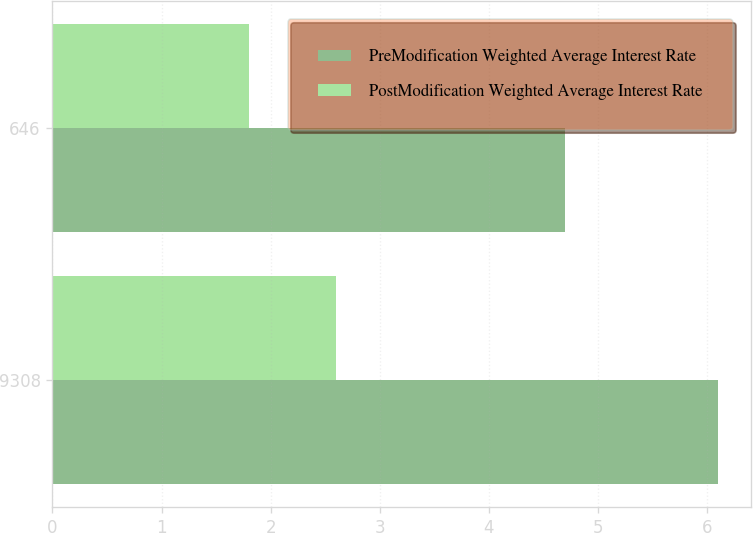<chart> <loc_0><loc_0><loc_500><loc_500><stacked_bar_chart><ecel><fcel>9308<fcel>646<nl><fcel>PreModification Weighted Average Interest Rate<fcel>6.1<fcel>4.7<nl><fcel>PostModification Weighted Average Interest Rate<fcel>2.6<fcel>1.8<nl></chart> 